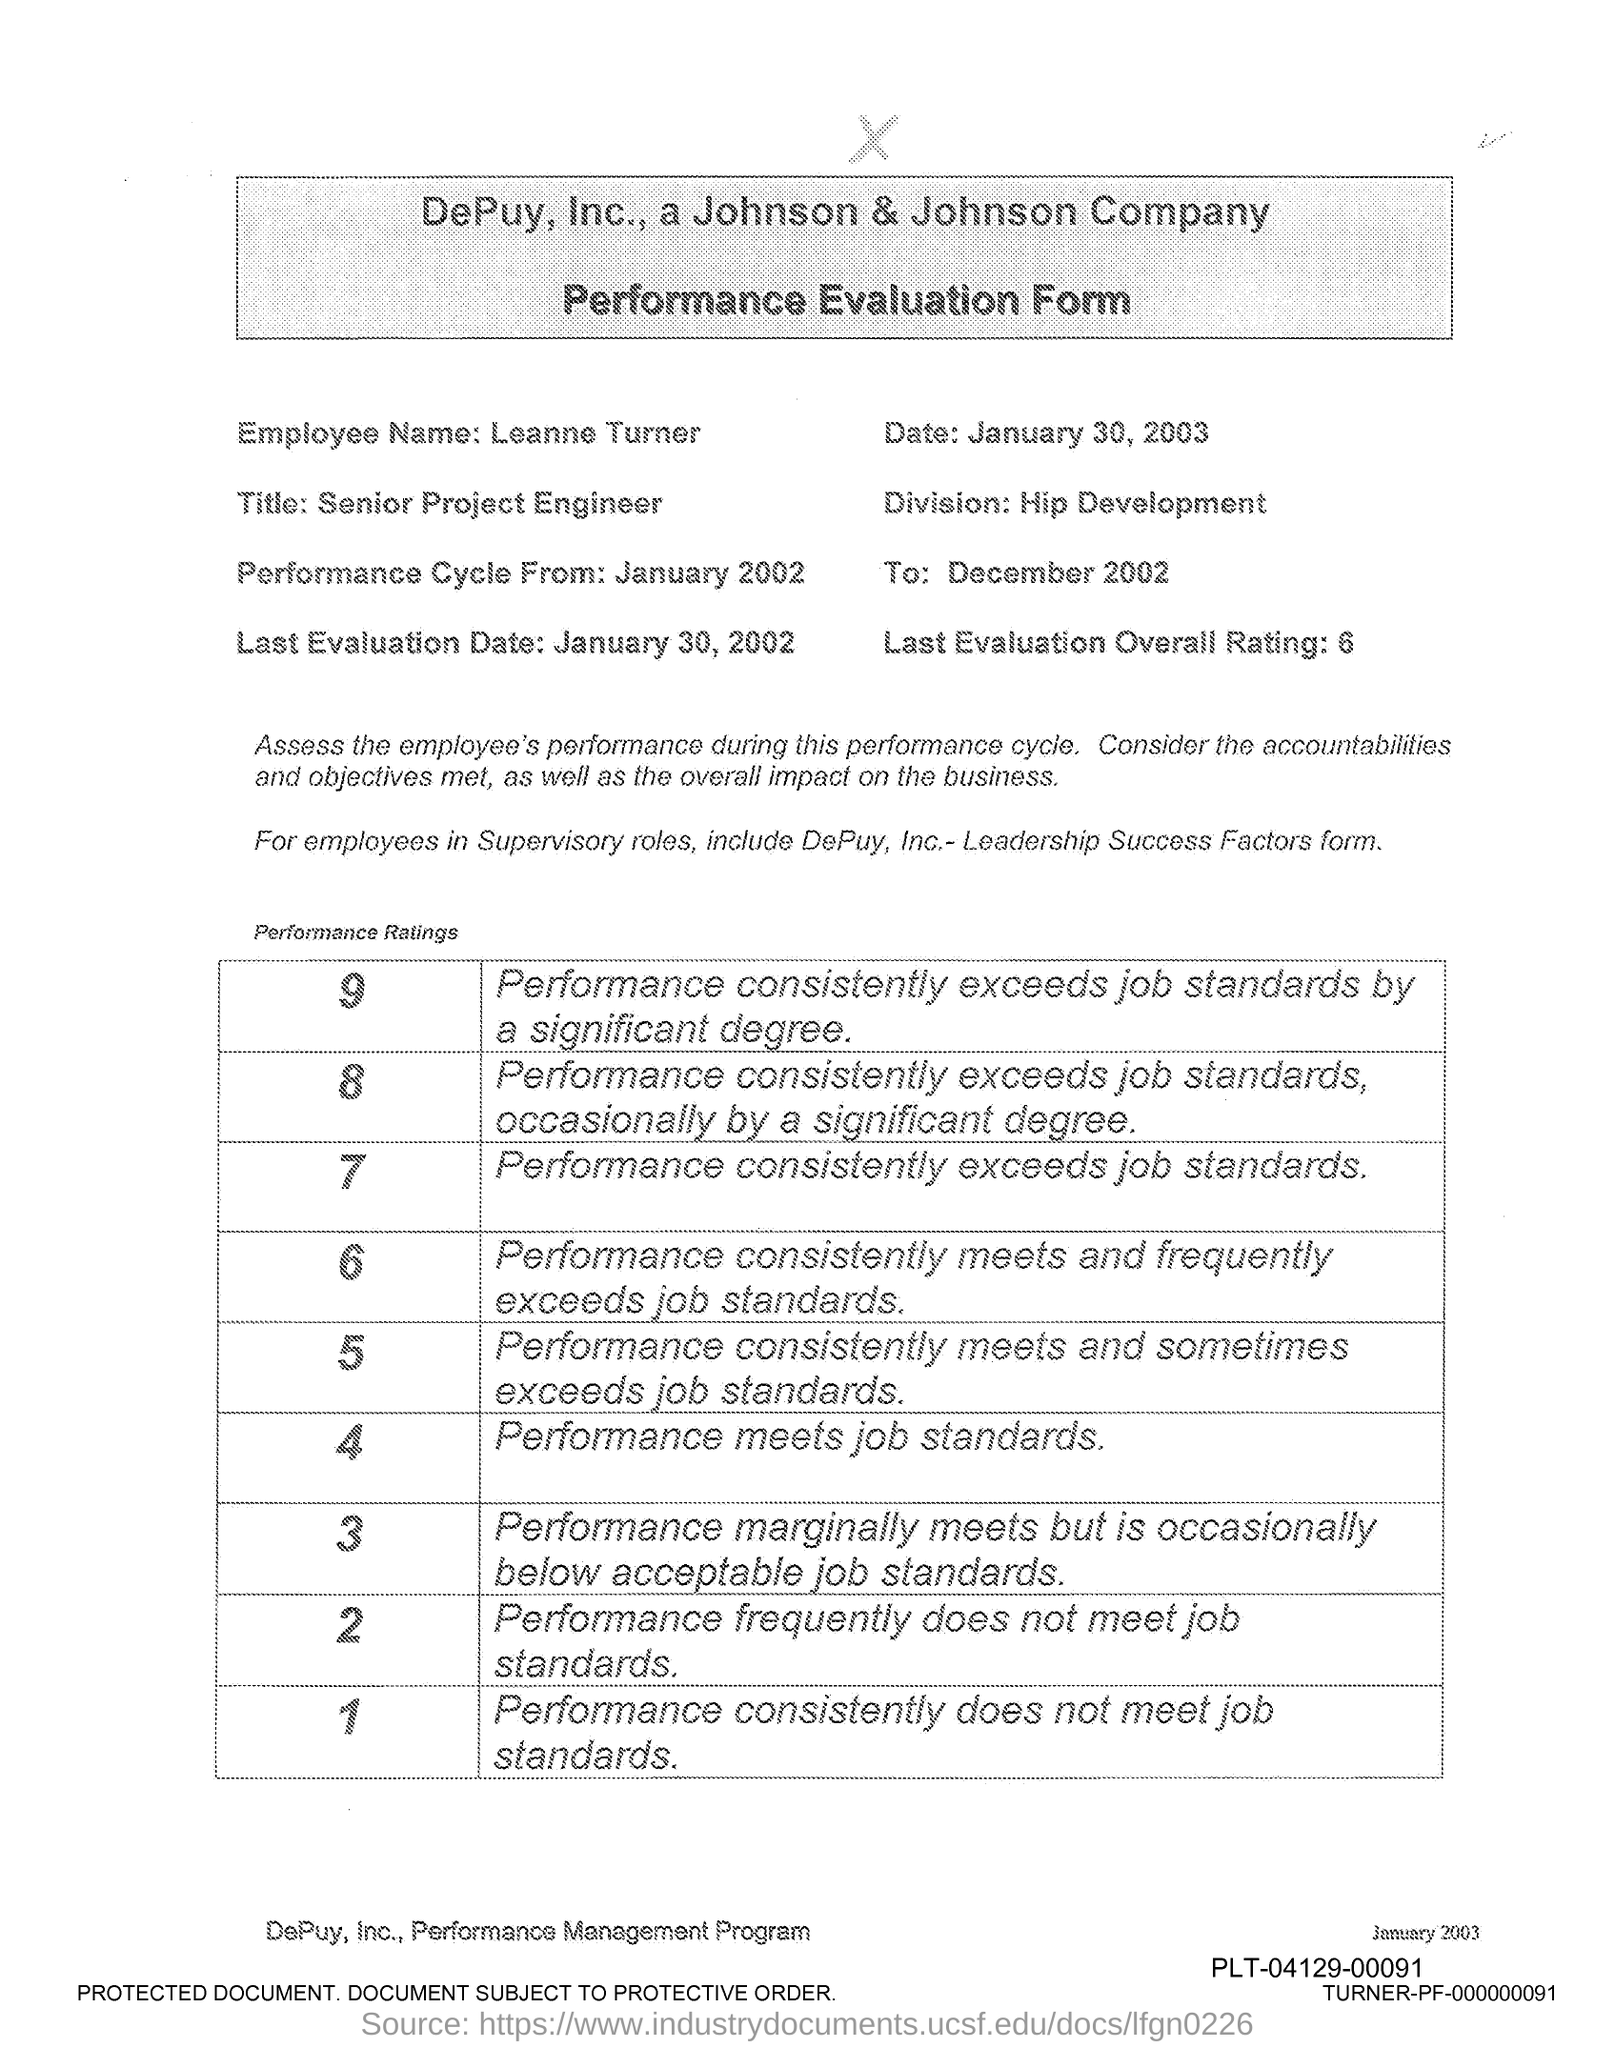What is the employee name given in the form?
Keep it short and to the point. Leanne Turner. What is the title of Leanne Turner?
Keep it short and to the point. Senior Project Engineer. What is the last evaluation date mentioned in the form?
Keep it short and to the point. January 30, 2002. What is the last evaluation overall rating mentioned in the form?
Make the answer very short. 6. What is the issued date of the performance evaluation form?
Keep it short and to the point. January 30, 2003. In which division, Leanne Turner works?
Make the answer very short. Hip Development. When does the performance cycle start as per the evaluation form?
Keep it short and to the point. January 2002. 